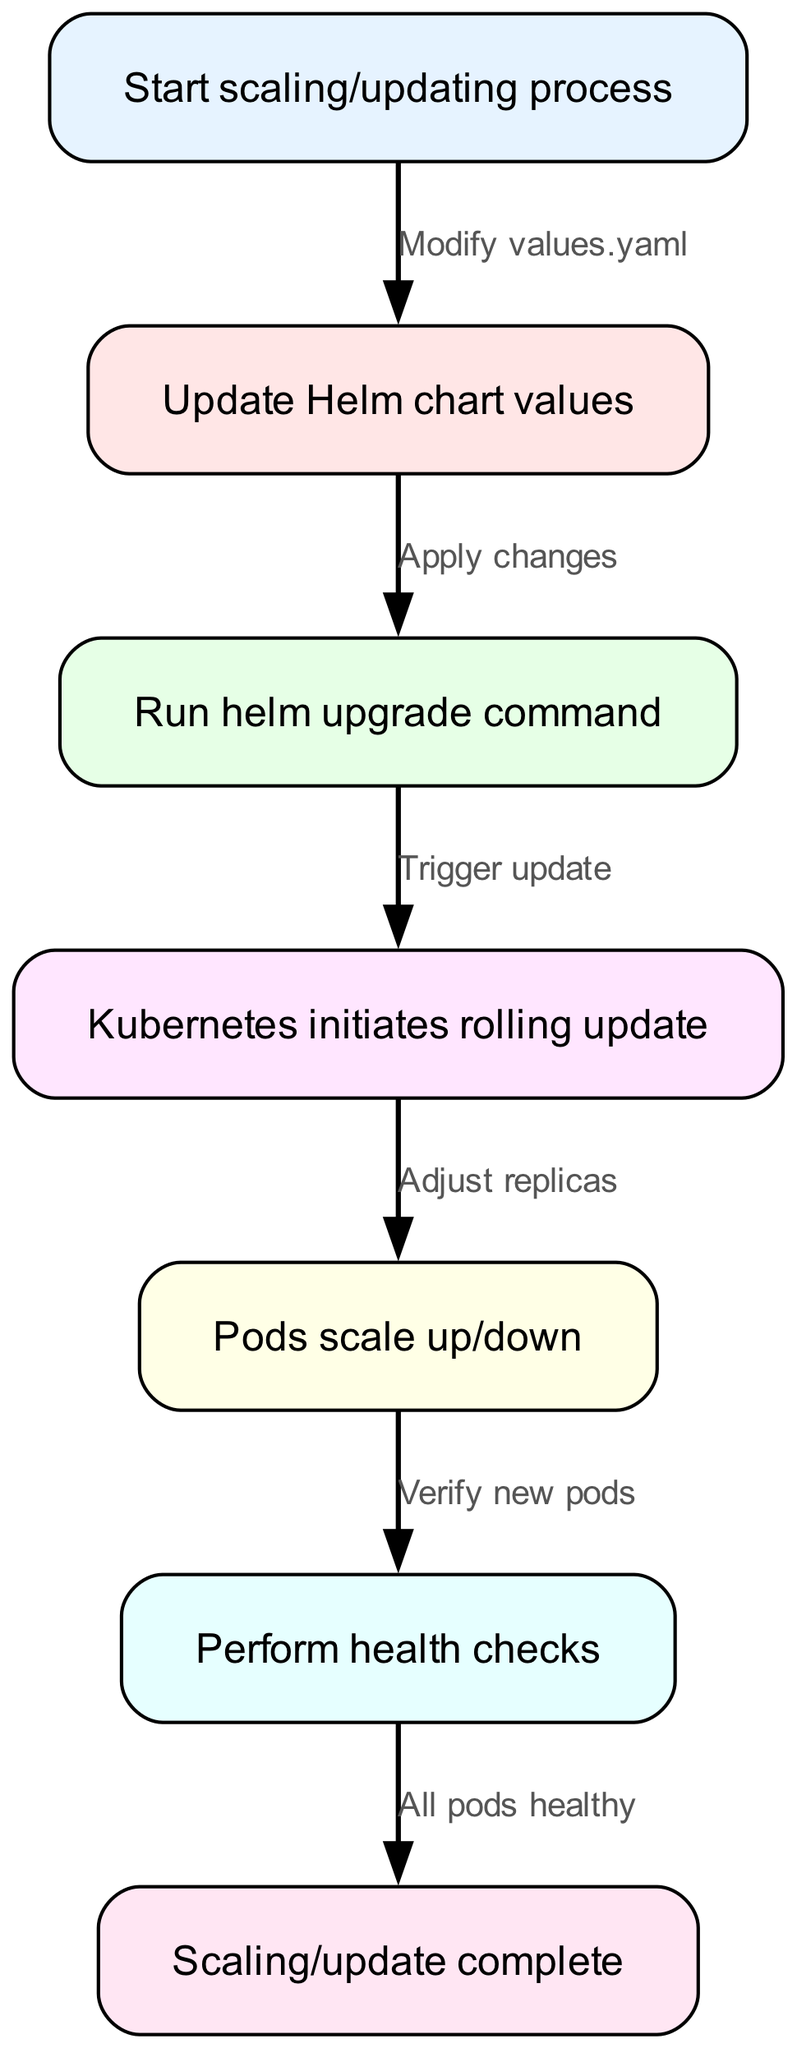What's the starting point of the flow? The starting point is labeled as "Start scaling/updating process". This node initiates the entire flow of scaling or updating applications in Kubernetes using Helm.
Answer: Start scaling/updating process How many nodes are present in the diagram? By counting the visual representation of each node in the flowchart, we identify a total of six distinct nodes that represent the different stages of the process.
Answer: 6 What is the action after updating the Helm chart values? The edge connecting "Update Helm chart values" to "Run helm upgrade command" shows that the next step is to apply the changes made in the values.yaml file.
Answer: Apply changes What happens after the helm upgrade command is executed? The trigger sequence following the helm upgrade command leads directly to the Kubernetes rollout, indicating that this step initiates the rolling update process.
Answer: Trigger update What must be completed before confirming scaling/update as complete? The final edge transitioning from "Perform health checks" to "Scaling/update complete" clarifies that all pods need to be healthy for the process to be considered complete.
Answer: All pods healthy Which step involves adjusting the number of replicas? The node labeled "Pods scale up/down" specifically refers to the action of adjusting the number of replicas during the rolling update initiated by Kubernetes.
Answer: Adjust replicas What triggers the Kubernetes rolling update? The direct relationship from the "Run helm upgrade command" node to the "Kubernetes initiates rolling update" node indicates that this action triggers the update process within Kubernetes.
Answer: Trigger update What kind of health verification is conducted in the process? The "Perform health checks" node indicates that health verification is a required step in ensuring the newly scaled pods are working correctly.
Answer: Verify new pods 